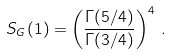<formula> <loc_0><loc_0><loc_500><loc_500>S _ { G } ( 1 ) = \left ( \frac { \Gamma ( 5 / 4 ) } { \Gamma ( 3 / 4 ) } \right ) ^ { 4 } \, .</formula> 